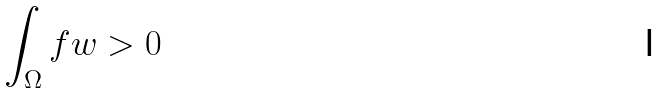Convert formula to latex. <formula><loc_0><loc_0><loc_500><loc_500>\int _ { \Omega } f w > 0</formula> 